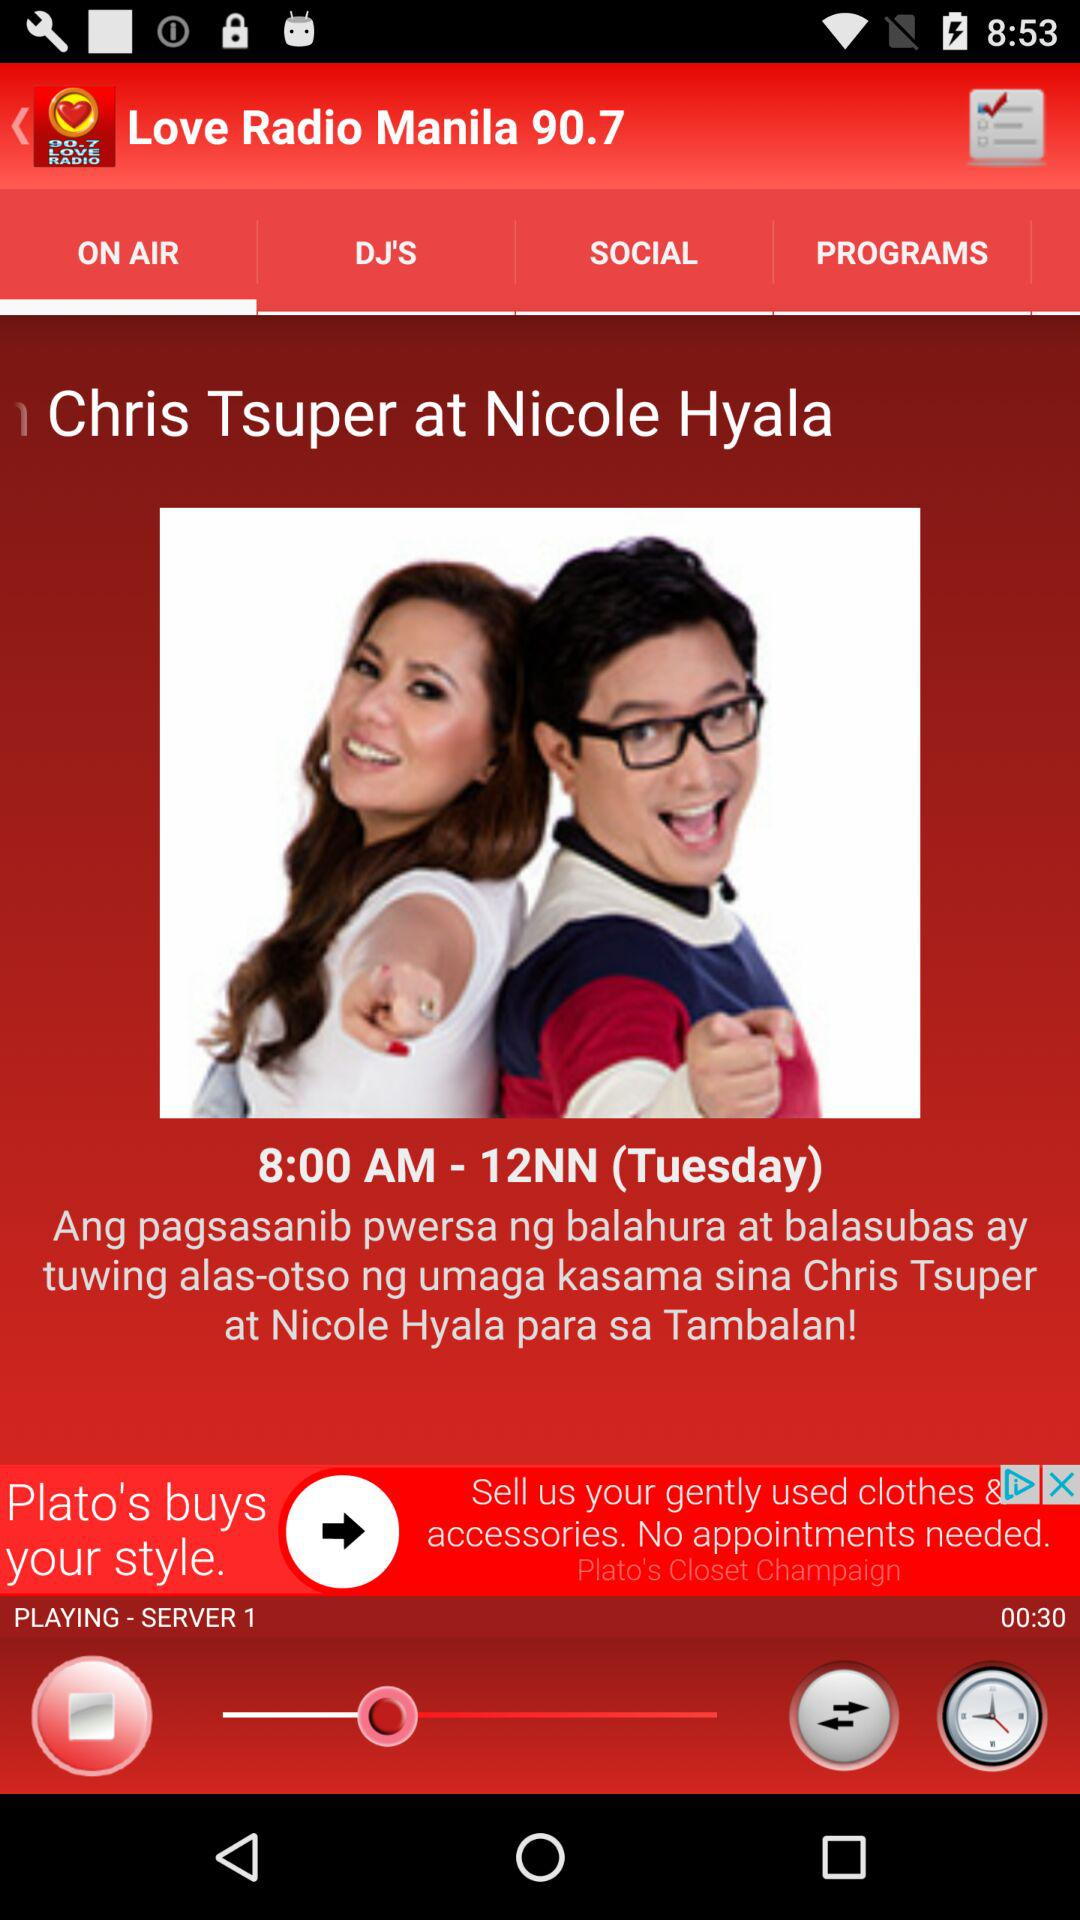On which day does the show air? The day is Tuesday. 